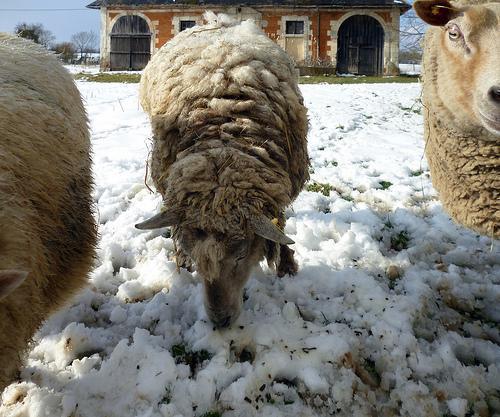How many sheep?
Give a very brief answer. 3. How many buildings?
Give a very brief answer. 1. How many trees?
Give a very brief answer. 3. 